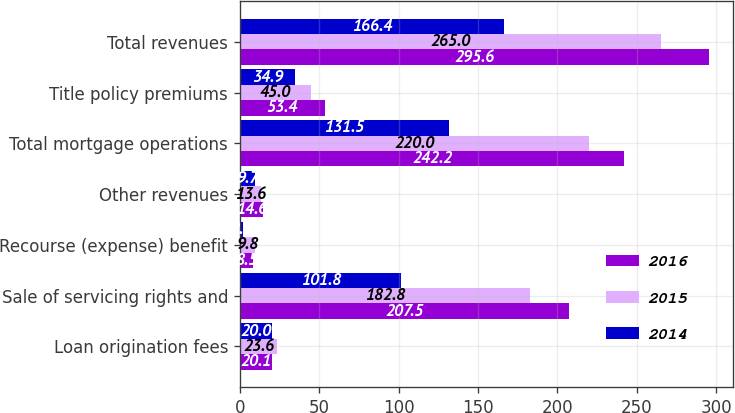Convert chart to OTSL. <chart><loc_0><loc_0><loc_500><loc_500><stacked_bar_chart><ecel><fcel>Loan origination fees<fcel>Sale of servicing rights and<fcel>Recourse (expense) benefit<fcel>Other revenues<fcel>Total mortgage operations<fcel>Title policy premiums<fcel>Total revenues<nl><fcel>2016<fcel>20.1<fcel>207.5<fcel>8.5<fcel>14.6<fcel>242.2<fcel>53.4<fcel>295.6<nl><fcel>2015<fcel>23.6<fcel>182.8<fcel>9.8<fcel>13.6<fcel>220<fcel>45<fcel>265<nl><fcel>2014<fcel>20<fcel>101.8<fcel>2.2<fcel>9.7<fcel>131.5<fcel>34.9<fcel>166.4<nl></chart> 